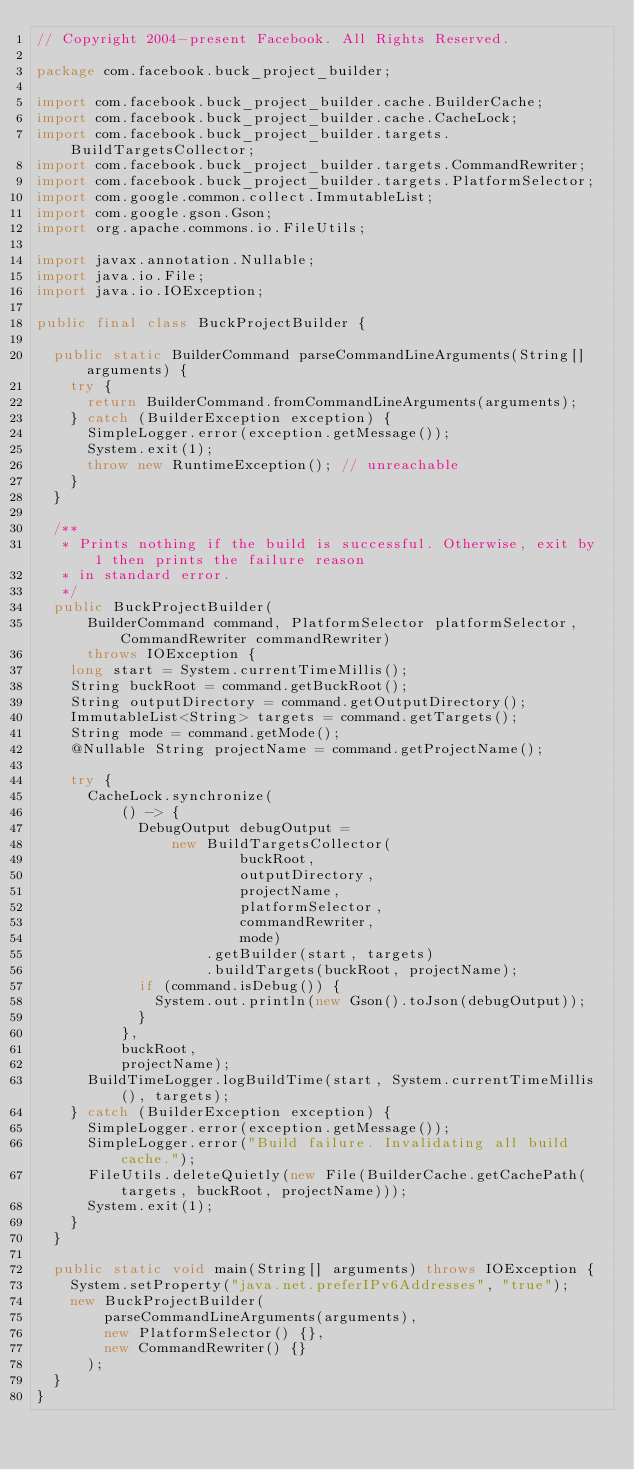<code> <loc_0><loc_0><loc_500><loc_500><_Java_>// Copyright 2004-present Facebook. All Rights Reserved.

package com.facebook.buck_project_builder;

import com.facebook.buck_project_builder.cache.BuilderCache;
import com.facebook.buck_project_builder.cache.CacheLock;
import com.facebook.buck_project_builder.targets.BuildTargetsCollector;
import com.facebook.buck_project_builder.targets.CommandRewriter;
import com.facebook.buck_project_builder.targets.PlatformSelector;
import com.google.common.collect.ImmutableList;
import com.google.gson.Gson;
import org.apache.commons.io.FileUtils;

import javax.annotation.Nullable;
import java.io.File;
import java.io.IOException;

public final class BuckProjectBuilder {

  public static BuilderCommand parseCommandLineArguments(String[] arguments) {
    try {
      return BuilderCommand.fromCommandLineArguments(arguments);
    } catch (BuilderException exception) {
      SimpleLogger.error(exception.getMessage());
      System.exit(1);
      throw new RuntimeException(); // unreachable
    }
  }

  /**
   * Prints nothing if the build is successful. Otherwise, exit by 1 then prints the failure reason
   * in standard error.
   */
  public BuckProjectBuilder(
      BuilderCommand command, PlatformSelector platformSelector, CommandRewriter commandRewriter)
      throws IOException {
    long start = System.currentTimeMillis();
    String buckRoot = command.getBuckRoot();
    String outputDirectory = command.getOutputDirectory();
    ImmutableList<String> targets = command.getTargets();
    String mode = command.getMode();
    @Nullable String projectName = command.getProjectName();

    try {
      CacheLock.synchronize(
          () -> {
            DebugOutput debugOutput =
                new BuildTargetsCollector(
                        buckRoot,
                        outputDirectory,
                        projectName,
                        platformSelector,
                        commandRewriter,
                        mode)
                    .getBuilder(start, targets)
                    .buildTargets(buckRoot, projectName);
            if (command.isDebug()) {
              System.out.println(new Gson().toJson(debugOutput));
            }
          },
          buckRoot,
          projectName);
      BuildTimeLogger.logBuildTime(start, System.currentTimeMillis(), targets);
    } catch (BuilderException exception) {
      SimpleLogger.error(exception.getMessage());
      SimpleLogger.error("Build failure. Invalidating all build cache.");
      FileUtils.deleteQuietly(new File(BuilderCache.getCachePath(targets, buckRoot, projectName)));
      System.exit(1);
    }
  }

  public static void main(String[] arguments) throws IOException {
    System.setProperty("java.net.preferIPv6Addresses", "true");
    new BuckProjectBuilder(
        parseCommandLineArguments(arguments),
        new PlatformSelector() {},
        new CommandRewriter() {}
      );
  }
}
</code> 